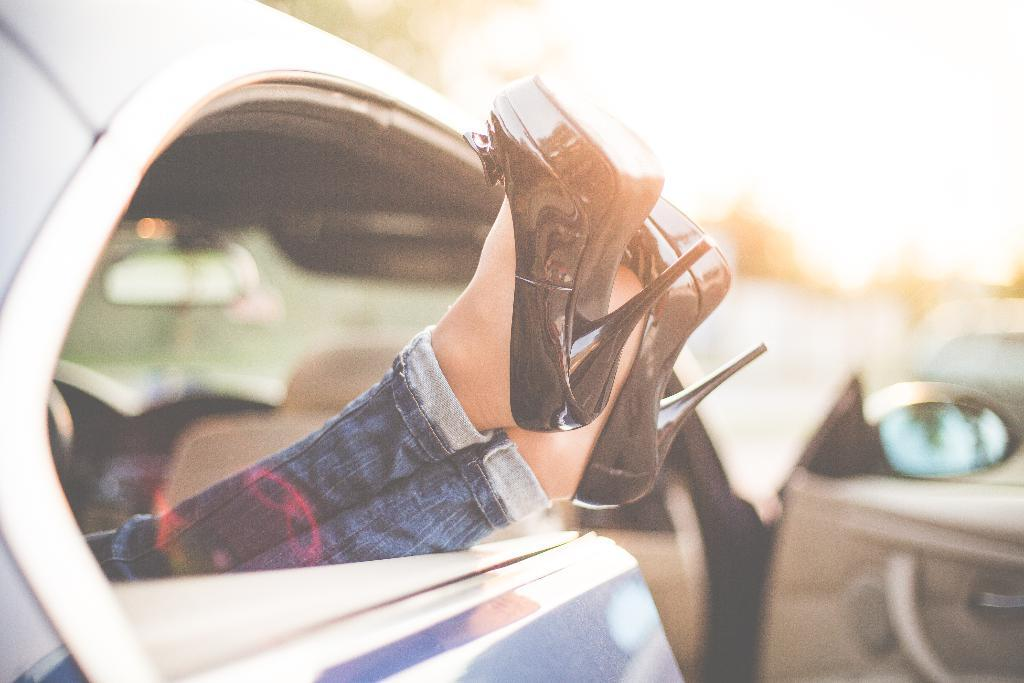What part of a person can be seen in the image? There are legs of a person in the image. What type of vehicle is present in the image? There is a car in the image. Can you describe the background of the image? The background of the image is blurred. What type of toothpaste is being used by the person in the image? There is no toothpaste present in the image; it only shows the legs of a person and a car. How many chairs are visible in the image? There are no chairs visible in the image. 